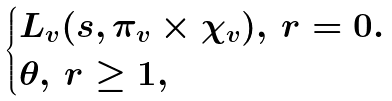<formula> <loc_0><loc_0><loc_500><loc_500>\begin{cases} L _ { v } ( s , \pi _ { v } \times \chi _ { v } ) , \, r = 0 . \\ \theta , \, r \geq 1 , \end{cases}</formula> 